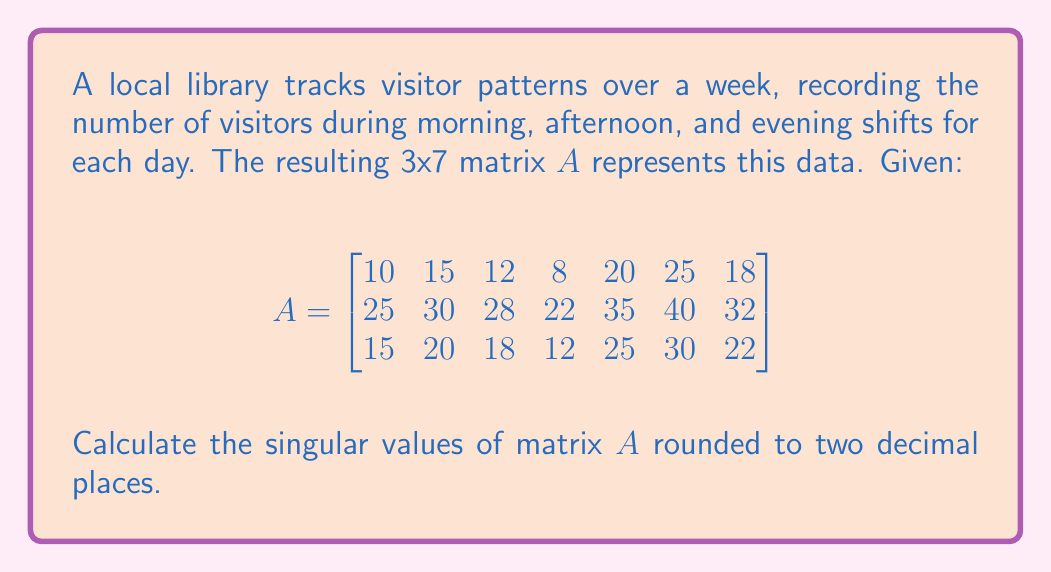Show me your answer to this math problem. To find the singular values of matrix $A$, we need to follow these steps:

1) First, calculate $A^TA$:

$$A^TA = \begin{bmatrix}
1450 & 2525 & 1750 \\
2525 & 4678 & 3150 \\
1750 & 3150 & 2218
\end{bmatrix}$$

2) Find the eigenvalues of $A^TA$. The characteristic equation is:

$\det(A^TA - \lambda I) = 0$

3) Solving this equation (which is a cubic equation) gives us the eigenvalues:

$\lambda_1 \approx 8346.39$
$\lambda_2 \approx 0.59$
$\lambda_3 \approx 0.02$

4) The singular values are the square roots of these eigenvalues:

$\sigma_1 = \sqrt{8346.39} \approx 91.36$
$\sigma_2 = \sqrt{0.59} \approx 0.77$
$\sigma_3 = \sqrt{0.02} \approx 0.14$

5) Rounding to two decimal places:

$\sigma_1 \approx 91.36$
$\sigma_2 \approx 0.77$
$\sigma_3 \approx 0.14$
Answer: $91.36, 0.77, 0.14$ 